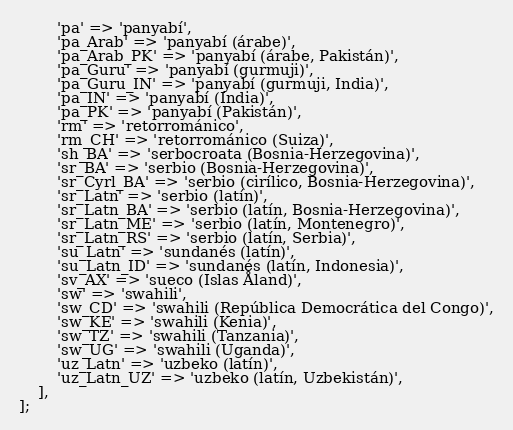<code> <loc_0><loc_0><loc_500><loc_500><_PHP_>        'pa' => 'panyabí',
        'pa_Arab' => 'panyabí (árabe)',
        'pa_Arab_PK' => 'panyabí (árabe, Pakistán)',
        'pa_Guru' => 'panyabí (gurmuji)',
        'pa_Guru_IN' => 'panyabí (gurmuji, India)',
        'pa_IN' => 'panyabí (India)',
        'pa_PK' => 'panyabí (Pakistán)',
        'rm' => 'retorrománico',
        'rm_CH' => 'retorrománico (Suiza)',
        'sh_BA' => 'serbocroata (Bosnia-Herzegovina)',
        'sr_BA' => 'serbio (Bosnia-Herzegovina)',
        'sr_Cyrl_BA' => 'serbio (cirílico, Bosnia-Herzegovina)',
        'sr_Latn' => 'serbio (latín)',
        'sr_Latn_BA' => 'serbio (latín, Bosnia-Herzegovina)',
        'sr_Latn_ME' => 'serbio (latín, Montenegro)',
        'sr_Latn_RS' => 'serbio (latín, Serbia)',
        'su_Latn' => 'sundanés (latín)',
        'su_Latn_ID' => 'sundanés (latín, Indonesia)',
        'sv_AX' => 'sueco (Islas Åland)',
        'sw' => 'swahili',
        'sw_CD' => 'swahili (República Democrática del Congo)',
        'sw_KE' => 'swahili (Kenia)',
        'sw_TZ' => 'swahili (Tanzania)',
        'sw_UG' => 'swahili (Uganda)',
        'uz_Latn' => 'uzbeko (latín)',
        'uz_Latn_UZ' => 'uzbeko (latín, Uzbekistán)',
    ],
];
</code> 